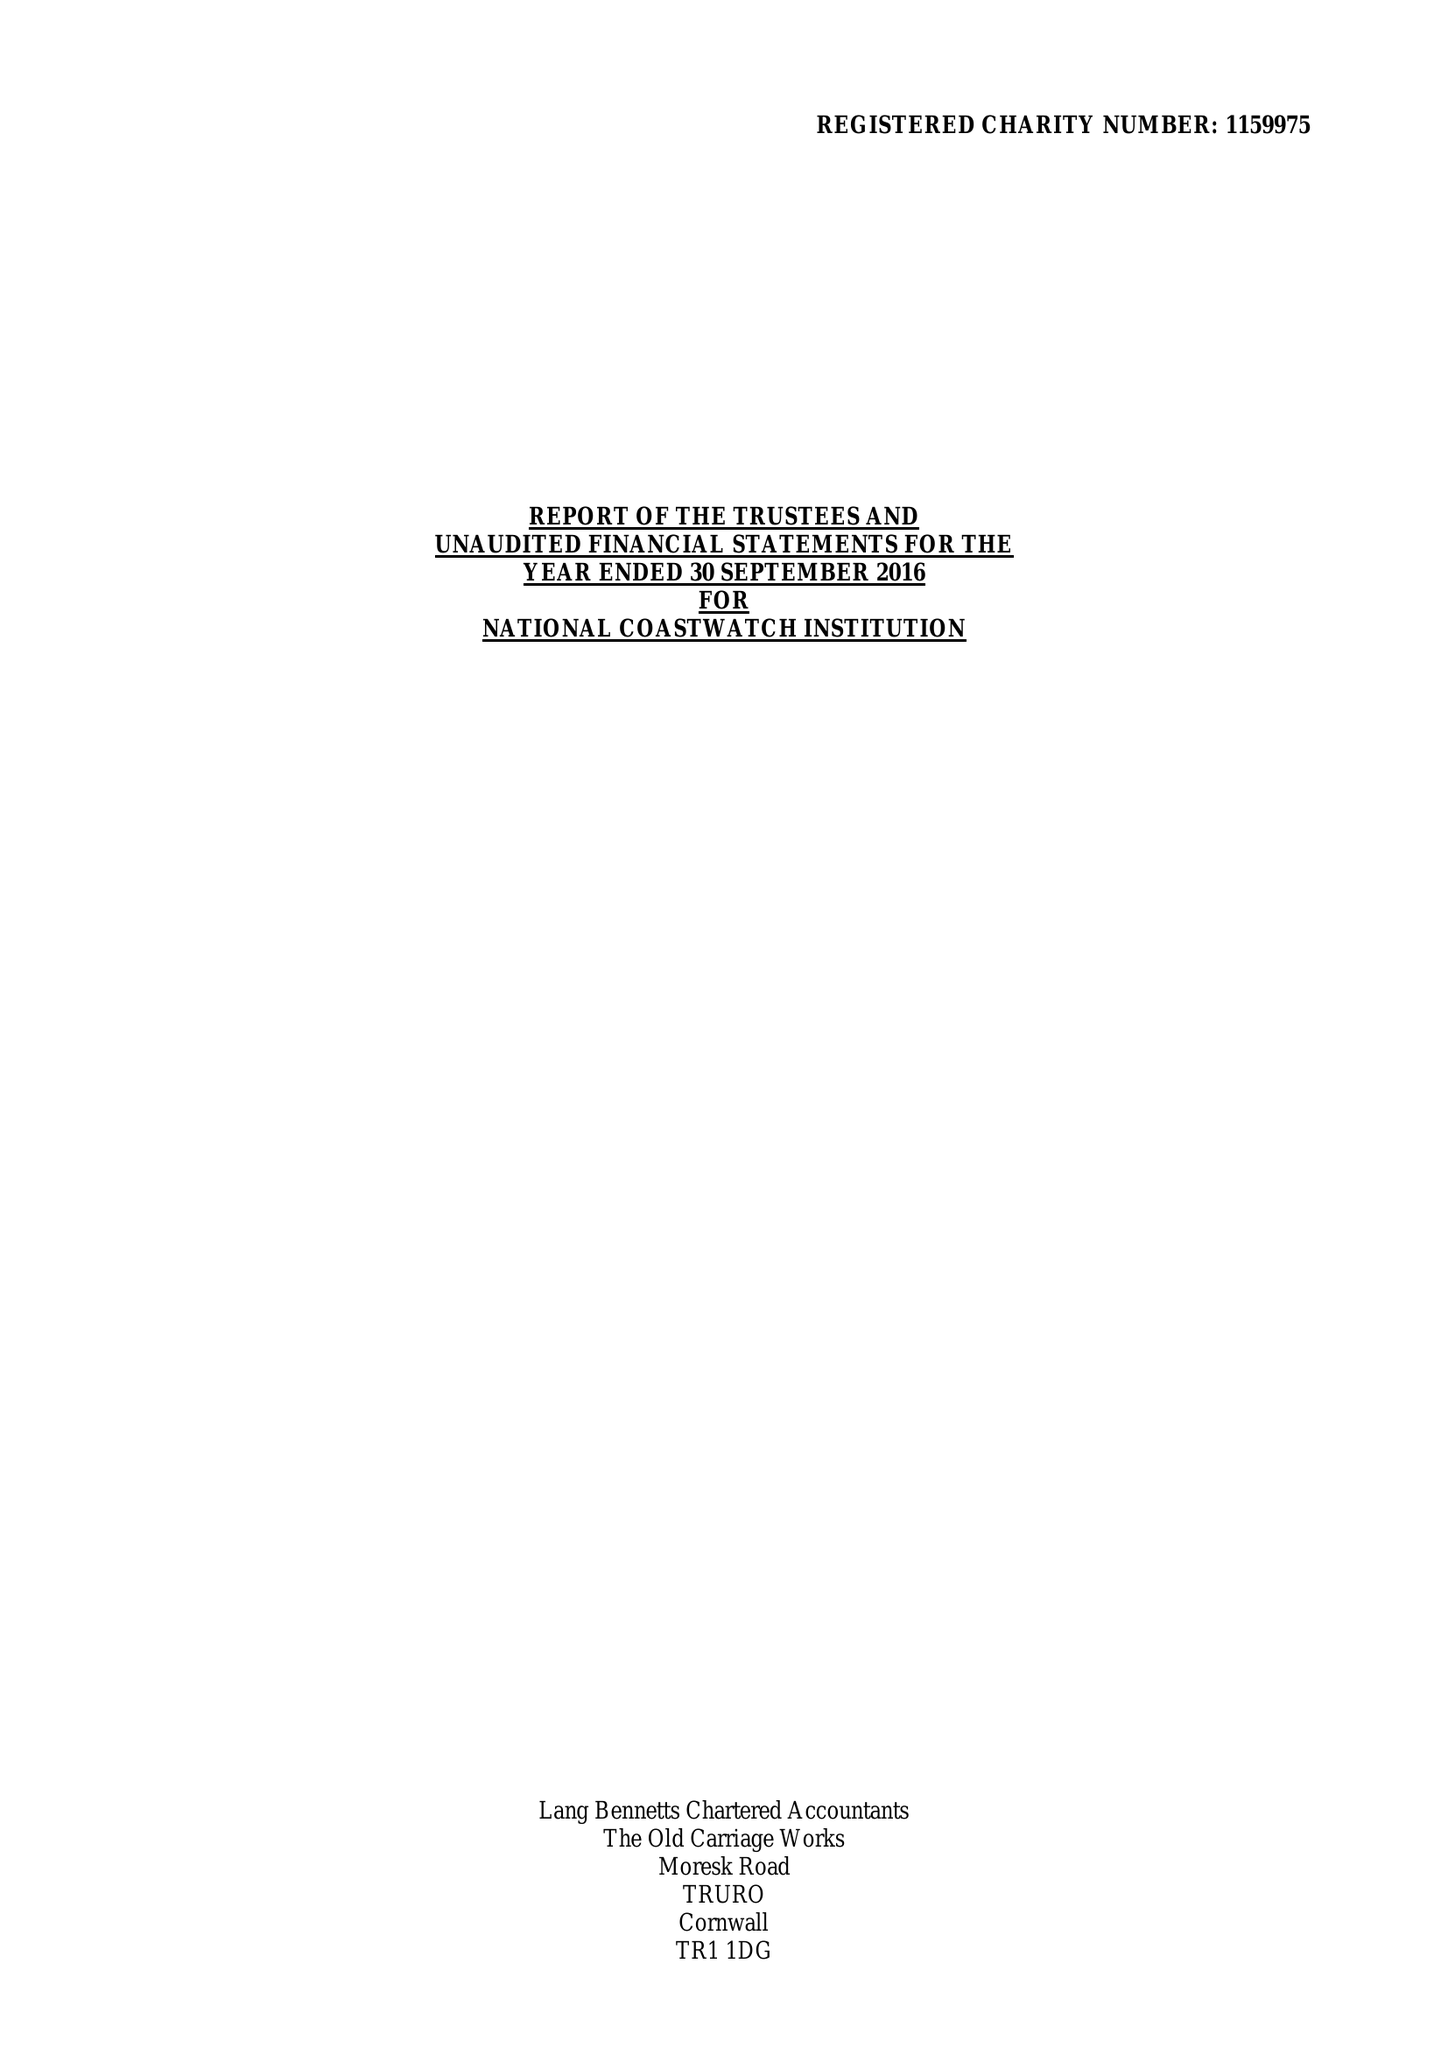What is the value for the address__post_town?
Answer the question using a single word or phrase. LISKEARD 